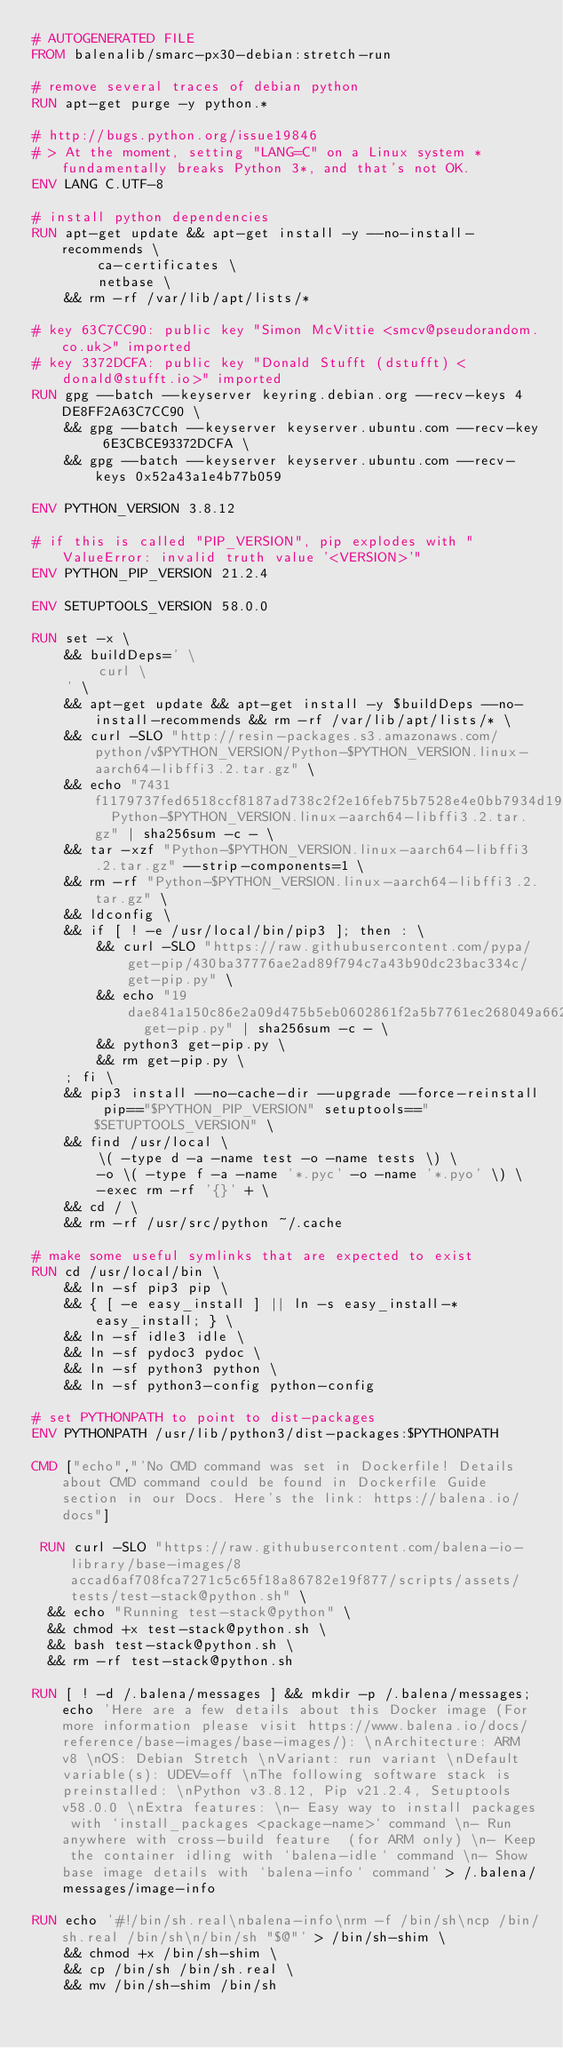Convert code to text. <code><loc_0><loc_0><loc_500><loc_500><_Dockerfile_># AUTOGENERATED FILE
FROM balenalib/smarc-px30-debian:stretch-run

# remove several traces of debian python
RUN apt-get purge -y python.*

# http://bugs.python.org/issue19846
# > At the moment, setting "LANG=C" on a Linux system *fundamentally breaks Python 3*, and that's not OK.
ENV LANG C.UTF-8

# install python dependencies
RUN apt-get update && apt-get install -y --no-install-recommends \
		ca-certificates \
		netbase \
	&& rm -rf /var/lib/apt/lists/*

# key 63C7CC90: public key "Simon McVittie <smcv@pseudorandom.co.uk>" imported
# key 3372DCFA: public key "Donald Stufft (dstufft) <donald@stufft.io>" imported
RUN gpg --batch --keyserver keyring.debian.org --recv-keys 4DE8FF2A63C7CC90 \
	&& gpg --batch --keyserver keyserver.ubuntu.com --recv-key 6E3CBCE93372DCFA \
	&& gpg --batch --keyserver keyserver.ubuntu.com --recv-keys 0x52a43a1e4b77b059

ENV PYTHON_VERSION 3.8.12

# if this is called "PIP_VERSION", pip explodes with "ValueError: invalid truth value '<VERSION>'"
ENV PYTHON_PIP_VERSION 21.2.4

ENV SETUPTOOLS_VERSION 58.0.0

RUN set -x \
	&& buildDeps=' \
		curl \
	' \
	&& apt-get update && apt-get install -y $buildDeps --no-install-recommends && rm -rf /var/lib/apt/lists/* \
	&& curl -SLO "http://resin-packages.s3.amazonaws.com/python/v$PYTHON_VERSION/Python-$PYTHON_VERSION.linux-aarch64-libffi3.2.tar.gz" \
	&& echo "7431f1179737fed6518ccf8187ad738c2f2e16feb75b7528e4e0bb7934d192cf  Python-$PYTHON_VERSION.linux-aarch64-libffi3.2.tar.gz" | sha256sum -c - \
	&& tar -xzf "Python-$PYTHON_VERSION.linux-aarch64-libffi3.2.tar.gz" --strip-components=1 \
	&& rm -rf "Python-$PYTHON_VERSION.linux-aarch64-libffi3.2.tar.gz" \
	&& ldconfig \
	&& if [ ! -e /usr/local/bin/pip3 ]; then : \
		&& curl -SLO "https://raw.githubusercontent.com/pypa/get-pip/430ba37776ae2ad89f794c7a43b90dc23bac334c/get-pip.py" \
		&& echo "19dae841a150c86e2a09d475b5eb0602861f2a5b7761ec268049a662dbd2bd0c  get-pip.py" | sha256sum -c - \
		&& python3 get-pip.py \
		&& rm get-pip.py \
	; fi \
	&& pip3 install --no-cache-dir --upgrade --force-reinstall pip=="$PYTHON_PIP_VERSION" setuptools=="$SETUPTOOLS_VERSION" \
	&& find /usr/local \
		\( -type d -a -name test -o -name tests \) \
		-o \( -type f -a -name '*.pyc' -o -name '*.pyo' \) \
		-exec rm -rf '{}' + \
	&& cd / \
	&& rm -rf /usr/src/python ~/.cache

# make some useful symlinks that are expected to exist
RUN cd /usr/local/bin \
	&& ln -sf pip3 pip \
	&& { [ -e easy_install ] || ln -s easy_install-* easy_install; } \
	&& ln -sf idle3 idle \
	&& ln -sf pydoc3 pydoc \
	&& ln -sf python3 python \
	&& ln -sf python3-config python-config

# set PYTHONPATH to point to dist-packages
ENV PYTHONPATH /usr/lib/python3/dist-packages:$PYTHONPATH

CMD ["echo","'No CMD command was set in Dockerfile! Details about CMD command could be found in Dockerfile Guide section in our Docs. Here's the link: https://balena.io/docs"]

 RUN curl -SLO "https://raw.githubusercontent.com/balena-io-library/base-images/8accad6af708fca7271c5c65f18a86782e19f877/scripts/assets/tests/test-stack@python.sh" \
  && echo "Running test-stack@python" \
  && chmod +x test-stack@python.sh \
  && bash test-stack@python.sh \
  && rm -rf test-stack@python.sh 

RUN [ ! -d /.balena/messages ] && mkdir -p /.balena/messages; echo 'Here are a few details about this Docker image (For more information please visit https://www.balena.io/docs/reference/base-images/base-images/): \nArchitecture: ARM v8 \nOS: Debian Stretch \nVariant: run variant \nDefault variable(s): UDEV=off \nThe following software stack is preinstalled: \nPython v3.8.12, Pip v21.2.4, Setuptools v58.0.0 \nExtra features: \n- Easy way to install packages with `install_packages <package-name>` command \n- Run anywhere with cross-build feature  (for ARM only) \n- Keep the container idling with `balena-idle` command \n- Show base image details with `balena-info` command' > /.balena/messages/image-info

RUN echo '#!/bin/sh.real\nbalena-info\nrm -f /bin/sh\ncp /bin/sh.real /bin/sh\n/bin/sh "$@"' > /bin/sh-shim \
	&& chmod +x /bin/sh-shim \
	&& cp /bin/sh /bin/sh.real \
	&& mv /bin/sh-shim /bin/sh</code> 